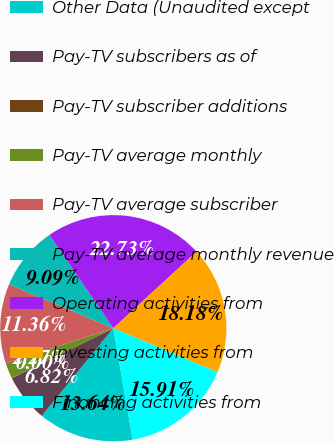<chart> <loc_0><loc_0><loc_500><loc_500><pie_chart><fcel>Other Data (Unaudited except<fcel>Pay-TV subscribers as of<fcel>Pay-TV subscriber additions<fcel>Pay-TV average monthly<fcel>Pay-TV average subscriber<fcel>Pay-TV average monthly revenue<fcel>Operating activities from<fcel>Investing activities from<fcel>Financing activities from<nl><fcel>13.64%<fcel>6.82%<fcel>0.0%<fcel>2.27%<fcel>11.36%<fcel>9.09%<fcel>22.73%<fcel>18.18%<fcel>15.91%<nl></chart> 